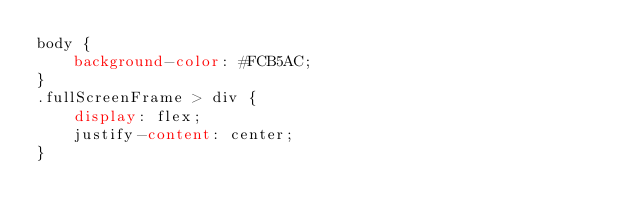<code> <loc_0><loc_0><loc_500><loc_500><_CSS_>body {
    background-color: #FCB5AC;
}
.fullScreenFrame > div {
    display: flex;
    justify-content: center;
}</code> 